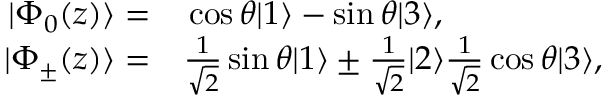<formula> <loc_0><loc_0><loc_500><loc_500>\begin{array} { r } { \begin{array} { r l } { | \Phi _ { 0 } ( z ) \rangle = } & \cos \theta | 1 \rangle - \sin \theta | 3 \rangle , } \\ { | \Phi _ { \pm } ( z ) \rangle = } & \frac { 1 } { \sqrt { 2 } } \sin \theta | 1 \rangle \pm \frac { 1 } { \sqrt { 2 } } | 2 \rangle \frac { 1 } { \sqrt { 2 } } \cos \theta | 3 \rangle , } \end{array} } \end{array}</formula> 